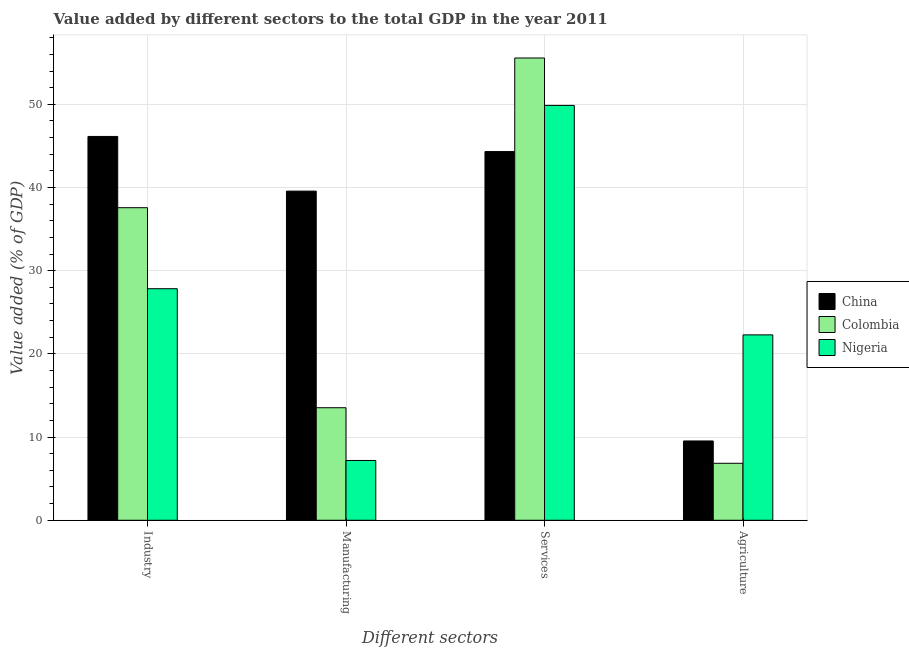How many groups of bars are there?
Make the answer very short. 4. Are the number of bars per tick equal to the number of legend labels?
Keep it short and to the point. Yes. Are the number of bars on each tick of the X-axis equal?
Your answer should be compact. Yes. How many bars are there on the 4th tick from the left?
Provide a succinct answer. 3. How many bars are there on the 1st tick from the right?
Provide a short and direct response. 3. What is the label of the 2nd group of bars from the left?
Offer a terse response. Manufacturing. What is the value added by agricultural sector in Nigeria?
Give a very brief answer. 22.29. Across all countries, what is the maximum value added by manufacturing sector?
Give a very brief answer. 39.57. Across all countries, what is the minimum value added by industrial sector?
Your response must be concise. 27.84. In which country was the value added by industrial sector maximum?
Keep it short and to the point. China. In which country was the value added by agricultural sector minimum?
Keep it short and to the point. Colombia. What is the total value added by services sector in the graph?
Ensure brevity in your answer.  149.77. What is the difference between the value added by services sector in Nigeria and that in Colombia?
Offer a terse response. -5.7. What is the difference between the value added by industrial sector in Nigeria and the value added by manufacturing sector in China?
Ensure brevity in your answer.  -11.73. What is the average value added by agricultural sector per country?
Your response must be concise. 12.89. What is the difference between the value added by industrial sector and value added by agricultural sector in Colombia?
Your answer should be compact. 30.73. What is the ratio of the value added by services sector in Nigeria to that in Colombia?
Give a very brief answer. 0.9. What is the difference between the highest and the second highest value added by agricultural sector?
Keep it short and to the point. 12.76. What is the difference between the highest and the lowest value added by services sector?
Your answer should be very brief. 11.25. In how many countries, is the value added by agricultural sector greater than the average value added by agricultural sector taken over all countries?
Give a very brief answer. 1. Is the sum of the value added by manufacturing sector in Colombia and Nigeria greater than the maximum value added by industrial sector across all countries?
Make the answer very short. No. What does the 1st bar from the left in Services represents?
Provide a short and direct response. China. Is it the case that in every country, the sum of the value added by industrial sector and value added by manufacturing sector is greater than the value added by services sector?
Offer a very short reply. No. How many bars are there?
Give a very brief answer. 12. Are the values on the major ticks of Y-axis written in scientific E-notation?
Give a very brief answer. No. How are the legend labels stacked?
Ensure brevity in your answer.  Vertical. What is the title of the graph?
Provide a succinct answer. Value added by different sectors to the total GDP in the year 2011. Does "San Marino" appear as one of the legend labels in the graph?
Your answer should be very brief. No. What is the label or title of the X-axis?
Give a very brief answer. Different sectors. What is the label or title of the Y-axis?
Keep it short and to the point. Value added (% of GDP). What is the Value added (% of GDP) of China in Industry?
Make the answer very short. 46.14. What is the Value added (% of GDP) of Colombia in Industry?
Offer a terse response. 37.58. What is the Value added (% of GDP) of Nigeria in Industry?
Your answer should be very brief. 27.84. What is the Value added (% of GDP) of China in Manufacturing?
Your answer should be very brief. 39.57. What is the Value added (% of GDP) of Colombia in Manufacturing?
Offer a terse response. 13.53. What is the Value added (% of GDP) in Nigeria in Manufacturing?
Give a very brief answer. 7.19. What is the Value added (% of GDP) of China in Services?
Ensure brevity in your answer.  44.32. What is the Value added (% of GDP) of Colombia in Services?
Your answer should be compact. 55.57. What is the Value added (% of GDP) in Nigeria in Services?
Provide a short and direct response. 49.87. What is the Value added (% of GDP) in China in Agriculture?
Your answer should be compact. 9.53. What is the Value added (% of GDP) of Colombia in Agriculture?
Provide a short and direct response. 6.85. What is the Value added (% of GDP) in Nigeria in Agriculture?
Provide a succinct answer. 22.29. Across all Different sectors, what is the maximum Value added (% of GDP) of China?
Your answer should be compact. 46.14. Across all Different sectors, what is the maximum Value added (% of GDP) of Colombia?
Your response must be concise. 55.57. Across all Different sectors, what is the maximum Value added (% of GDP) of Nigeria?
Ensure brevity in your answer.  49.87. Across all Different sectors, what is the minimum Value added (% of GDP) of China?
Offer a terse response. 9.53. Across all Different sectors, what is the minimum Value added (% of GDP) of Colombia?
Your response must be concise. 6.85. Across all Different sectors, what is the minimum Value added (% of GDP) in Nigeria?
Your answer should be very brief. 7.19. What is the total Value added (% of GDP) of China in the graph?
Your answer should be compact. 139.57. What is the total Value added (% of GDP) in Colombia in the graph?
Offer a terse response. 113.53. What is the total Value added (% of GDP) in Nigeria in the graph?
Give a very brief answer. 107.19. What is the difference between the Value added (% of GDP) of China in Industry and that in Manufacturing?
Ensure brevity in your answer.  6.57. What is the difference between the Value added (% of GDP) of Colombia in Industry and that in Manufacturing?
Offer a very short reply. 24.05. What is the difference between the Value added (% of GDP) in Nigeria in Industry and that in Manufacturing?
Give a very brief answer. 20.65. What is the difference between the Value added (% of GDP) of China in Industry and that in Services?
Offer a terse response. 1.82. What is the difference between the Value added (% of GDP) in Colombia in Industry and that in Services?
Make the answer very short. -18. What is the difference between the Value added (% of GDP) of Nigeria in Industry and that in Services?
Provide a short and direct response. -22.04. What is the difference between the Value added (% of GDP) of China in Industry and that in Agriculture?
Make the answer very short. 36.61. What is the difference between the Value added (% of GDP) in Colombia in Industry and that in Agriculture?
Give a very brief answer. 30.73. What is the difference between the Value added (% of GDP) in Nigeria in Industry and that in Agriculture?
Ensure brevity in your answer.  5.55. What is the difference between the Value added (% of GDP) in China in Manufacturing and that in Services?
Your answer should be very brief. -4.75. What is the difference between the Value added (% of GDP) of Colombia in Manufacturing and that in Services?
Keep it short and to the point. -42.04. What is the difference between the Value added (% of GDP) of Nigeria in Manufacturing and that in Services?
Provide a short and direct response. -42.68. What is the difference between the Value added (% of GDP) of China in Manufacturing and that in Agriculture?
Give a very brief answer. 30.04. What is the difference between the Value added (% of GDP) in Colombia in Manufacturing and that in Agriculture?
Make the answer very short. 6.68. What is the difference between the Value added (% of GDP) in Nigeria in Manufacturing and that in Agriculture?
Ensure brevity in your answer.  -15.1. What is the difference between the Value added (% of GDP) in China in Services and that in Agriculture?
Offer a terse response. 34.79. What is the difference between the Value added (% of GDP) in Colombia in Services and that in Agriculture?
Offer a terse response. 48.73. What is the difference between the Value added (% of GDP) of Nigeria in Services and that in Agriculture?
Offer a terse response. 27.58. What is the difference between the Value added (% of GDP) in China in Industry and the Value added (% of GDP) in Colombia in Manufacturing?
Give a very brief answer. 32.61. What is the difference between the Value added (% of GDP) of China in Industry and the Value added (% of GDP) of Nigeria in Manufacturing?
Offer a terse response. 38.95. What is the difference between the Value added (% of GDP) of Colombia in Industry and the Value added (% of GDP) of Nigeria in Manufacturing?
Offer a terse response. 30.39. What is the difference between the Value added (% of GDP) in China in Industry and the Value added (% of GDP) in Colombia in Services?
Your answer should be compact. -9.43. What is the difference between the Value added (% of GDP) in China in Industry and the Value added (% of GDP) in Nigeria in Services?
Give a very brief answer. -3.73. What is the difference between the Value added (% of GDP) in Colombia in Industry and the Value added (% of GDP) in Nigeria in Services?
Provide a succinct answer. -12.3. What is the difference between the Value added (% of GDP) in China in Industry and the Value added (% of GDP) in Colombia in Agriculture?
Your answer should be very brief. 39.29. What is the difference between the Value added (% of GDP) of China in Industry and the Value added (% of GDP) of Nigeria in Agriculture?
Make the answer very short. 23.85. What is the difference between the Value added (% of GDP) in Colombia in Industry and the Value added (% of GDP) in Nigeria in Agriculture?
Offer a terse response. 15.29. What is the difference between the Value added (% of GDP) in China in Manufacturing and the Value added (% of GDP) in Colombia in Services?
Offer a very short reply. -16. What is the difference between the Value added (% of GDP) in China in Manufacturing and the Value added (% of GDP) in Nigeria in Services?
Your answer should be very brief. -10.3. What is the difference between the Value added (% of GDP) of Colombia in Manufacturing and the Value added (% of GDP) of Nigeria in Services?
Ensure brevity in your answer.  -36.34. What is the difference between the Value added (% of GDP) in China in Manufacturing and the Value added (% of GDP) in Colombia in Agriculture?
Make the answer very short. 32.72. What is the difference between the Value added (% of GDP) in China in Manufacturing and the Value added (% of GDP) in Nigeria in Agriculture?
Keep it short and to the point. 17.28. What is the difference between the Value added (% of GDP) of Colombia in Manufacturing and the Value added (% of GDP) of Nigeria in Agriculture?
Make the answer very short. -8.76. What is the difference between the Value added (% of GDP) of China in Services and the Value added (% of GDP) of Colombia in Agriculture?
Offer a very short reply. 37.47. What is the difference between the Value added (% of GDP) of China in Services and the Value added (% of GDP) of Nigeria in Agriculture?
Provide a succinct answer. 22.03. What is the difference between the Value added (% of GDP) in Colombia in Services and the Value added (% of GDP) in Nigeria in Agriculture?
Your response must be concise. 33.28. What is the average Value added (% of GDP) in China per Different sectors?
Make the answer very short. 34.89. What is the average Value added (% of GDP) in Colombia per Different sectors?
Give a very brief answer. 28.38. What is the average Value added (% of GDP) of Nigeria per Different sectors?
Make the answer very short. 26.8. What is the difference between the Value added (% of GDP) of China and Value added (% of GDP) of Colombia in Industry?
Provide a succinct answer. 8.57. What is the difference between the Value added (% of GDP) of China and Value added (% of GDP) of Nigeria in Industry?
Offer a terse response. 18.31. What is the difference between the Value added (% of GDP) of Colombia and Value added (% of GDP) of Nigeria in Industry?
Your answer should be compact. 9.74. What is the difference between the Value added (% of GDP) in China and Value added (% of GDP) in Colombia in Manufacturing?
Offer a very short reply. 26.04. What is the difference between the Value added (% of GDP) in China and Value added (% of GDP) in Nigeria in Manufacturing?
Keep it short and to the point. 32.38. What is the difference between the Value added (% of GDP) of Colombia and Value added (% of GDP) of Nigeria in Manufacturing?
Your answer should be very brief. 6.34. What is the difference between the Value added (% of GDP) of China and Value added (% of GDP) of Colombia in Services?
Offer a terse response. -11.25. What is the difference between the Value added (% of GDP) in China and Value added (% of GDP) in Nigeria in Services?
Your answer should be compact. -5.55. What is the difference between the Value added (% of GDP) in Colombia and Value added (% of GDP) in Nigeria in Services?
Your answer should be compact. 5.7. What is the difference between the Value added (% of GDP) in China and Value added (% of GDP) in Colombia in Agriculture?
Your answer should be very brief. 2.68. What is the difference between the Value added (% of GDP) in China and Value added (% of GDP) in Nigeria in Agriculture?
Provide a short and direct response. -12.76. What is the difference between the Value added (% of GDP) of Colombia and Value added (% of GDP) of Nigeria in Agriculture?
Provide a short and direct response. -15.44. What is the ratio of the Value added (% of GDP) of China in Industry to that in Manufacturing?
Ensure brevity in your answer.  1.17. What is the ratio of the Value added (% of GDP) in Colombia in Industry to that in Manufacturing?
Keep it short and to the point. 2.78. What is the ratio of the Value added (% of GDP) in Nigeria in Industry to that in Manufacturing?
Keep it short and to the point. 3.87. What is the ratio of the Value added (% of GDP) in China in Industry to that in Services?
Keep it short and to the point. 1.04. What is the ratio of the Value added (% of GDP) of Colombia in Industry to that in Services?
Provide a short and direct response. 0.68. What is the ratio of the Value added (% of GDP) in Nigeria in Industry to that in Services?
Provide a succinct answer. 0.56. What is the ratio of the Value added (% of GDP) in China in Industry to that in Agriculture?
Your answer should be very brief. 4.84. What is the ratio of the Value added (% of GDP) of Colombia in Industry to that in Agriculture?
Offer a terse response. 5.49. What is the ratio of the Value added (% of GDP) of Nigeria in Industry to that in Agriculture?
Provide a succinct answer. 1.25. What is the ratio of the Value added (% of GDP) in China in Manufacturing to that in Services?
Offer a terse response. 0.89. What is the ratio of the Value added (% of GDP) of Colombia in Manufacturing to that in Services?
Provide a succinct answer. 0.24. What is the ratio of the Value added (% of GDP) of Nigeria in Manufacturing to that in Services?
Make the answer very short. 0.14. What is the ratio of the Value added (% of GDP) of China in Manufacturing to that in Agriculture?
Offer a terse response. 4.15. What is the ratio of the Value added (% of GDP) of Colombia in Manufacturing to that in Agriculture?
Provide a short and direct response. 1.98. What is the ratio of the Value added (% of GDP) of Nigeria in Manufacturing to that in Agriculture?
Your response must be concise. 0.32. What is the ratio of the Value added (% of GDP) in China in Services to that in Agriculture?
Your response must be concise. 4.65. What is the ratio of the Value added (% of GDP) in Colombia in Services to that in Agriculture?
Provide a succinct answer. 8.11. What is the ratio of the Value added (% of GDP) of Nigeria in Services to that in Agriculture?
Provide a succinct answer. 2.24. What is the difference between the highest and the second highest Value added (% of GDP) in China?
Offer a very short reply. 1.82. What is the difference between the highest and the second highest Value added (% of GDP) in Colombia?
Offer a very short reply. 18. What is the difference between the highest and the second highest Value added (% of GDP) in Nigeria?
Your response must be concise. 22.04. What is the difference between the highest and the lowest Value added (% of GDP) of China?
Your response must be concise. 36.61. What is the difference between the highest and the lowest Value added (% of GDP) in Colombia?
Make the answer very short. 48.73. What is the difference between the highest and the lowest Value added (% of GDP) of Nigeria?
Keep it short and to the point. 42.68. 